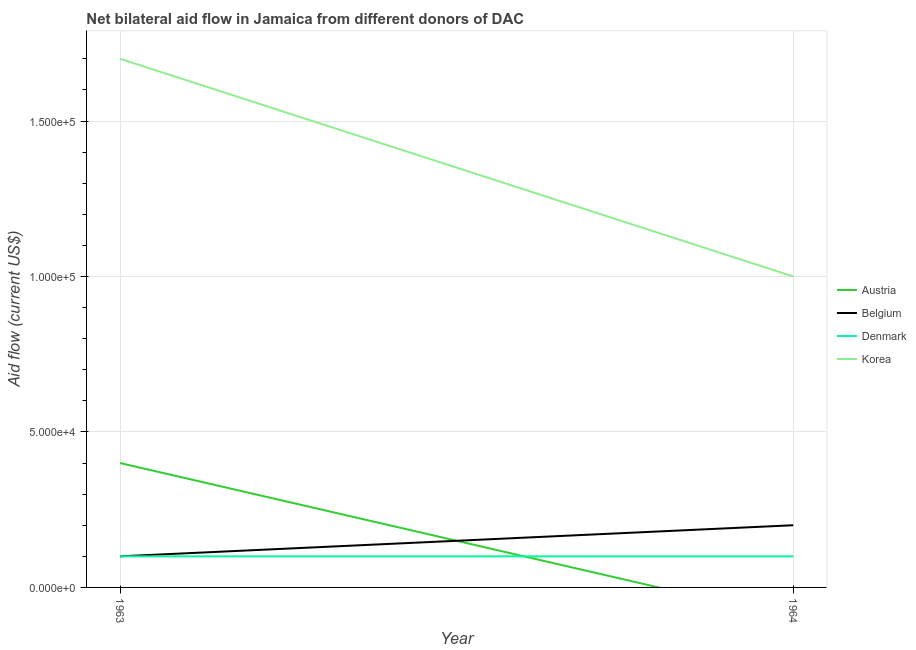Is the number of lines equal to the number of legend labels?
Give a very brief answer. No. What is the amount of aid given by korea in 1964?
Your response must be concise. 1.00e+05. Across all years, what is the maximum amount of aid given by korea?
Your answer should be compact. 1.70e+05. Across all years, what is the minimum amount of aid given by austria?
Ensure brevity in your answer.  0. What is the total amount of aid given by denmark in the graph?
Ensure brevity in your answer.  2.00e+04. What is the difference between the amount of aid given by belgium in 1963 and that in 1964?
Ensure brevity in your answer.  -10000. What is the difference between the amount of aid given by austria in 1964 and the amount of aid given by denmark in 1963?
Make the answer very short. -10000. What is the average amount of aid given by denmark per year?
Offer a terse response. 10000. In the year 1963, what is the difference between the amount of aid given by austria and amount of aid given by denmark?
Give a very brief answer. 3.00e+04. Is the amount of aid given by korea in 1963 less than that in 1964?
Your answer should be very brief. No. In how many years, is the amount of aid given by korea greater than the average amount of aid given by korea taken over all years?
Offer a terse response. 1. Is it the case that in every year, the sum of the amount of aid given by korea and amount of aid given by denmark is greater than the sum of amount of aid given by belgium and amount of aid given by austria?
Your answer should be compact. No. Does the amount of aid given by denmark monotonically increase over the years?
Your answer should be very brief. No. Is the amount of aid given by austria strictly greater than the amount of aid given by korea over the years?
Offer a very short reply. No. How many lines are there?
Your response must be concise. 4. How many years are there in the graph?
Keep it short and to the point. 2. What is the difference between two consecutive major ticks on the Y-axis?
Keep it short and to the point. 5.00e+04. Does the graph contain any zero values?
Offer a very short reply. Yes. Does the graph contain grids?
Keep it short and to the point. Yes. Where does the legend appear in the graph?
Give a very brief answer. Center right. How many legend labels are there?
Offer a terse response. 4. What is the title of the graph?
Offer a terse response. Net bilateral aid flow in Jamaica from different donors of DAC. Does "Secondary" appear as one of the legend labels in the graph?
Your response must be concise. No. What is the label or title of the X-axis?
Ensure brevity in your answer.  Year. What is the label or title of the Y-axis?
Your answer should be very brief. Aid flow (current US$). What is the Aid flow (current US$) in Belgium in 1963?
Offer a terse response. 10000. What is the Aid flow (current US$) of Denmark in 1963?
Provide a succinct answer. 10000. What is the Aid flow (current US$) in Austria in 1964?
Your answer should be compact. 0. What is the Aid flow (current US$) in Belgium in 1964?
Provide a succinct answer. 2.00e+04. What is the Aid flow (current US$) in Korea in 1964?
Offer a terse response. 1.00e+05. Across all years, what is the maximum Aid flow (current US$) in Korea?
Give a very brief answer. 1.70e+05. Across all years, what is the minimum Aid flow (current US$) of Belgium?
Your response must be concise. 10000. Across all years, what is the minimum Aid flow (current US$) in Denmark?
Your answer should be very brief. 10000. Across all years, what is the minimum Aid flow (current US$) in Korea?
Give a very brief answer. 1.00e+05. What is the total Aid flow (current US$) of Belgium in the graph?
Make the answer very short. 3.00e+04. What is the total Aid flow (current US$) in Denmark in the graph?
Keep it short and to the point. 2.00e+04. What is the difference between the Aid flow (current US$) in Belgium in 1963 and that in 1964?
Give a very brief answer. -10000. What is the difference between the Aid flow (current US$) in Denmark in 1963 and that in 1964?
Make the answer very short. 0. What is the difference between the Aid flow (current US$) in Korea in 1963 and that in 1964?
Offer a terse response. 7.00e+04. What is the difference between the Aid flow (current US$) in Austria in 1963 and the Aid flow (current US$) in Belgium in 1964?
Your response must be concise. 2.00e+04. What is the difference between the Aid flow (current US$) in Austria in 1963 and the Aid flow (current US$) in Korea in 1964?
Your answer should be very brief. -6.00e+04. What is the difference between the Aid flow (current US$) in Belgium in 1963 and the Aid flow (current US$) in Korea in 1964?
Provide a short and direct response. -9.00e+04. What is the difference between the Aid flow (current US$) in Denmark in 1963 and the Aid flow (current US$) in Korea in 1964?
Make the answer very short. -9.00e+04. What is the average Aid flow (current US$) in Austria per year?
Provide a short and direct response. 2.00e+04. What is the average Aid flow (current US$) in Belgium per year?
Provide a short and direct response. 1.50e+04. What is the average Aid flow (current US$) in Denmark per year?
Give a very brief answer. 10000. What is the average Aid flow (current US$) of Korea per year?
Make the answer very short. 1.35e+05. In the year 1963, what is the difference between the Aid flow (current US$) in Austria and Aid flow (current US$) in Belgium?
Give a very brief answer. 3.00e+04. In the year 1963, what is the difference between the Aid flow (current US$) of Belgium and Aid flow (current US$) of Denmark?
Ensure brevity in your answer.  0. In the year 1963, what is the difference between the Aid flow (current US$) of Belgium and Aid flow (current US$) of Korea?
Give a very brief answer. -1.60e+05. In the year 1963, what is the difference between the Aid flow (current US$) of Denmark and Aid flow (current US$) of Korea?
Give a very brief answer. -1.60e+05. In the year 1964, what is the difference between the Aid flow (current US$) of Belgium and Aid flow (current US$) of Korea?
Your answer should be very brief. -8.00e+04. What is the ratio of the Aid flow (current US$) of Belgium in 1963 to that in 1964?
Offer a terse response. 0.5. What is the ratio of the Aid flow (current US$) of Korea in 1963 to that in 1964?
Offer a very short reply. 1.7. What is the difference between the highest and the second highest Aid flow (current US$) of Denmark?
Your answer should be very brief. 0. 